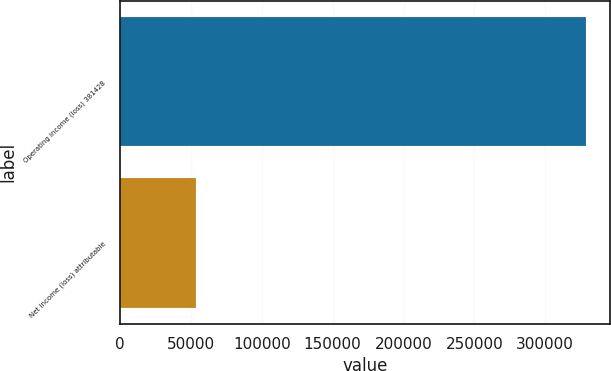Convert chart. <chart><loc_0><loc_0><loc_500><loc_500><bar_chart><fcel>Operating income (loss) 381428<fcel>Net income (loss) attributable<nl><fcel>329070<fcel>53382<nl></chart> 